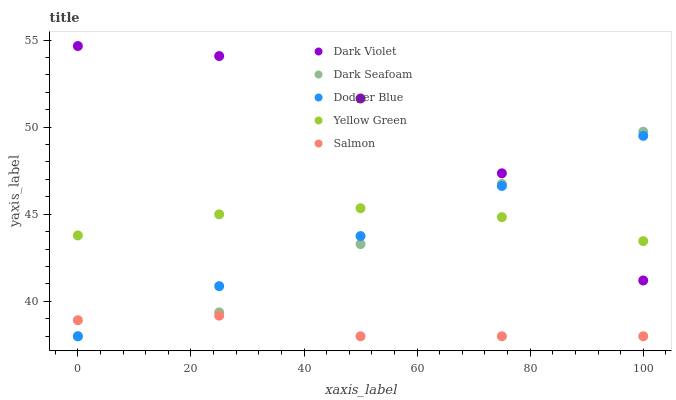Does Salmon have the minimum area under the curve?
Answer yes or no. Yes. Does Dark Violet have the maximum area under the curve?
Answer yes or no. Yes. Does Dark Seafoam have the minimum area under the curve?
Answer yes or no. No. Does Dark Seafoam have the maximum area under the curve?
Answer yes or no. No. Is Dodger Blue the smoothest?
Answer yes or no. Yes. Is Dark Violet the roughest?
Answer yes or no. Yes. Is Dark Seafoam the smoothest?
Answer yes or no. No. Is Dark Seafoam the roughest?
Answer yes or no. No. Does Salmon have the lowest value?
Answer yes or no. Yes. Does Yellow Green have the lowest value?
Answer yes or no. No. Does Dark Violet have the highest value?
Answer yes or no. Yes. Does Dark Seafoam have the highest value?
Answer yes or no. No. Is Salmon less than Dark Violet?
Answer yes or no. Yes. Is Yellow Green greater than Salmon?
Answer yes or no. Yes. Does Salmon intersect Dark Seafoam?
Answer yes or no. Yes. Is Salmon less than Dark Seafoam?
Answer yes or no. No. Is Salmon greater than Dark Seafoam?
Answer yes or no. No. Does Salmon intersect Dark Violet?
Answer yes or no. No. 